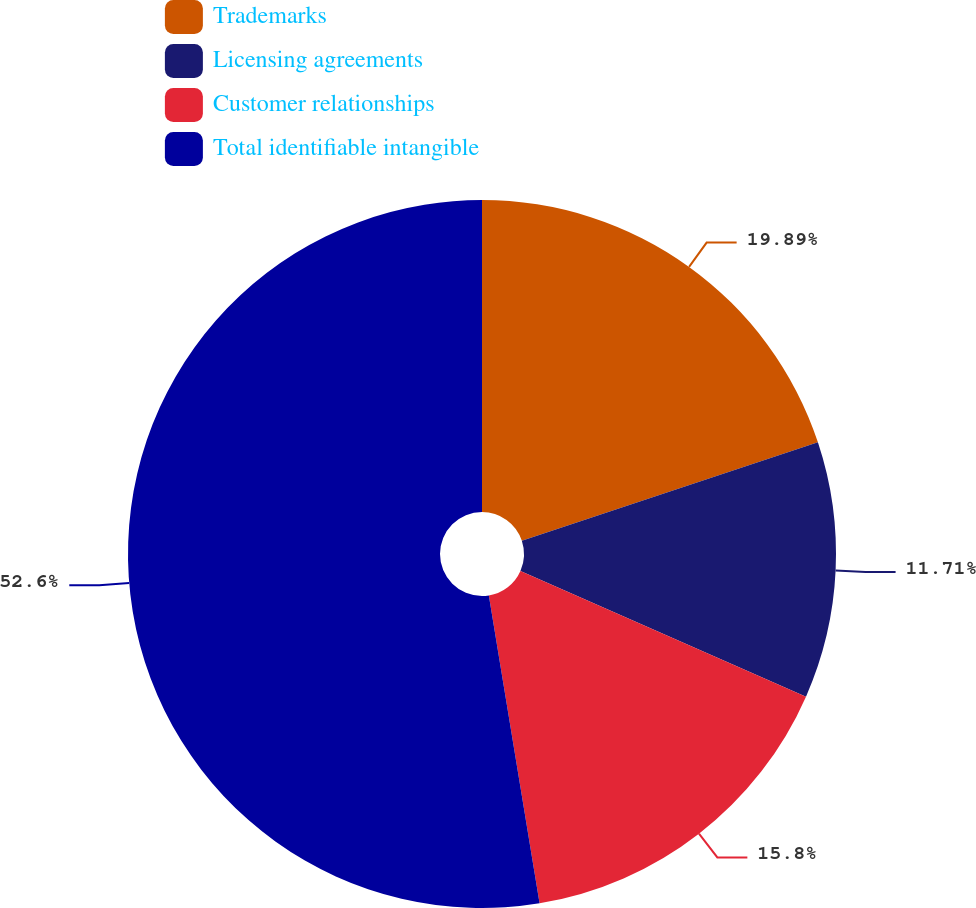Convert chart. <chart><loc_0><loc_0><loc_500><loc_500><pie_chart><fcel>Trademarks<fcel>Licensing agreements<fcel>Customer relationships<fcel>Total identifiable intangible<nl><fcel>19.89%<fcel>11.71%<fcel>15.8%<fcel>52.6%<nl></chart> 